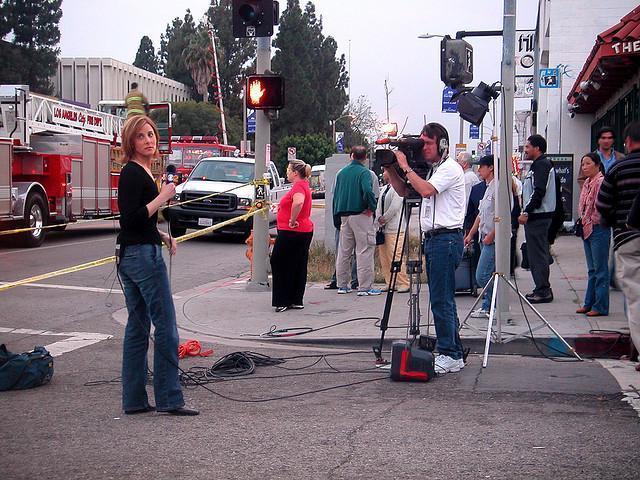How many backpacks can be seen?
Give a very brief answer. 1. How many trucks are in the photo?
Give a very brief answer. 2. How many people can be seen?
Give a very brief answer. 9. 